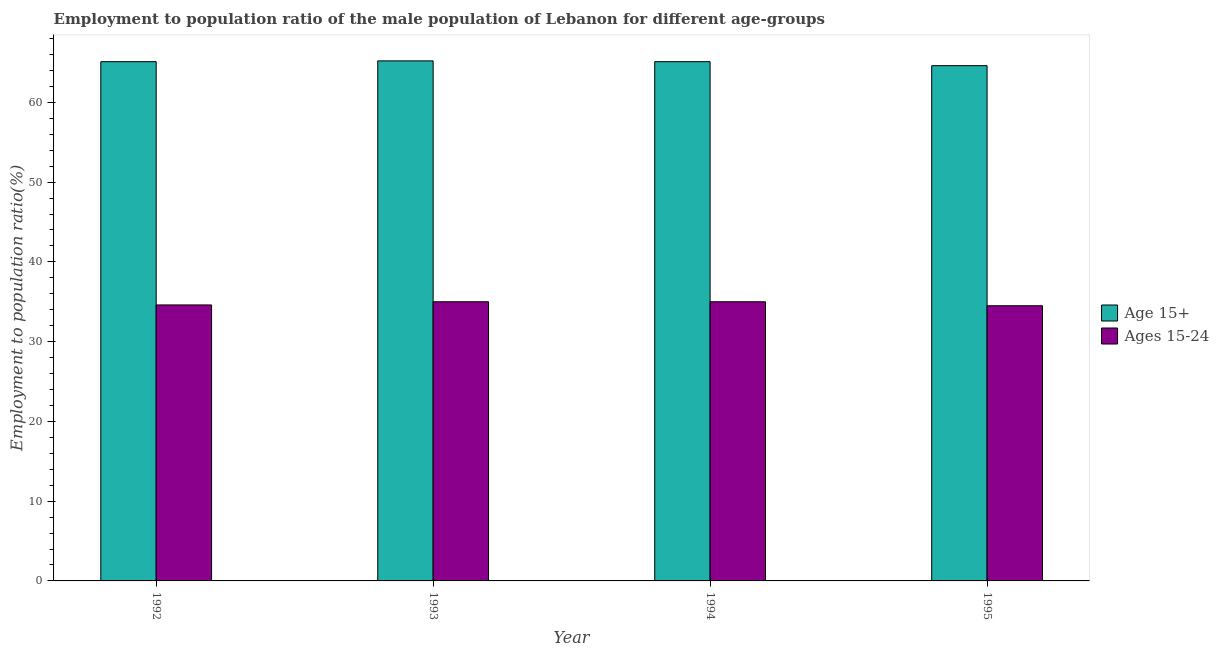How many different coloured bars are there?
Make the answer very short. 2. How many groups of bars are there?
Make the answer very short. 4. Are the number of bars on each tick of the X-axis equal?
Provide a short and direct response. Yes. How many bars are there on the 2nd tick from the left?
Offer a very short reply. 2. What is the label of the 2nd group of bars from the left?
Provide a succinct answer. 1993. What is the employment to population ratio(age 15+) in 1993?
Ensure brevity in your answer.  65.2. Across all years, what is the minimum employment to population ratio(age 15+)?
Your response must be concise. 64.6. In which year was the employment to population ratio(age 15+) maximum?
Your answer should be very brief. 1993. In which year was the employment to population ratio(age 15-24) minimum?
Your answer should be compact. 1995. What is the total employment to population ratio(age 15+) in the graph?
Your response must be concise. 260. What is the average employment to population ratio(age 15-24) per year?
Ensure brevity in your answer.  34.77. In the year 1994, what is the difference between the employment to population ratio(age 15+) and employment to population ratio(age 15-24)?
Offer a very short reply. 0. In how many years, is the employment to population ratio(age 15+) greater than 40 %?
Provide a short and direct response. 4. What is the ratio of the employment to population ratio(age 15+) in 1993 to that in 1994?
Make the answer very short. 1. Is the employment to population ratio(age 15-24) in 1992 less than that in 1994?
Give a very brief answer. Yes. What is the difference between the highest and the second highest employment to population ratio(age 15+)?
Keep it short and to the point. 0.1. What is the difference between the highest and the lowest employment to population ratio(age 15+)?
Provide a succinct answer. 0.6. What does the 2nd bar from the left in 1995 represents?
Make the answer very short. Ages 15-24. What does the 1st bar from the right in 1994 represents?
Your answer should be compact. Ages 15-24. Are the values on the major ticks of Y-axis written in scientific E-notation?
Keep it short and to the point. No. Does the graph contain grids?
Your answer should be compact. No. How many legend labels are there?
Ensure brevity in your answer.  2. How are the legend labels stacked?
Give a very brief answer. Vertical. What is the title of the graph?
Offer a very short reply. Employment to population ratio of the male population of Lebanon for different age-groups. Does "Investment" appear as one of the legend labels in the graph?
Keep it short and to the point. No. What is the label or title of the X-axis?
Your answer should be compact. Year. What is the Employment to population ratio(%) of Age 15+ in 1992?
Ensure brevity in your answer.  65.1. What is the Employment to population ratio(%) in Ages 15-24 in 1992?
Your answer should be compact. 34.6. What is the Employment to population ratio(%) in Age 15+ in 1993?
Your response must be concise. 65.2. What is the Employment to population ratio(%) of Ages 15-24 in 1993?
Keep it short and to the point. 35. What is the Employment to population ratio(%) of Age 15+ in 1994?
Your answer should be compact. 65.1. What is the Employment to population ratio(%) in Ages 15-24 in 1994?
Ensure brevity in your answer.  35. What is the Employment to population ratio(%) in Age 15+ in 1995?
Your answer should be very brief. 64.6. What is the Employment to population ratio(%) of Ages 15-24 in 1995?
Offer a very short reply. 34.5. Across all years, what is the maximum Employment to population ratio(%) of Age 15+?
Offer a terse response. 65.2. Across all years, what is the maximum Employment to population ratio(%) of Ages 15-24?
Make the answer very short. 35. Across all years, what is the minimum Employment to population ratio(%) in Age 15+?
Keep it short and to the point. 64.6. Across all years, what is the minimum Employment to population ratio(%) of Ages 15-24?
Your answer should be compact. 34.5. What is the total Employment to population ratio(%) of Age 15+ in the graph?
Your answer should be compact. 260. What is the total Employment to population ratio(%) of Ages 15-24 in the graph?
Your response must be concise. 139.1. What is the difference between the Employment to population ratio(%) of Age 15+ in 1992 and that in 1993?
Your response must be concise. -0.1. What is the difference between the Employment to population ratio(%) of Ages 15-24 in 1992 and that in 1993?
Offer a terse response. -0.4. What is the difference between the Employment to population ratio(%) in Age 15+ in 1992 and that in 1995?
Offer a terse response. 0.5. What is the difference between the Employment to population ratio(%) in Ages 15-24 in 1992 and that in 1995?
Keep it short and to the point. 0.1. What is the difference between the Employment to population ratio(%) of Age 15+ in 1993 and that in 1995?
Your answer should be very brief. 0.6. What is the difference between the Employment to population ratio(%) of Age 15+ in 1994 and that in 1995?
Provide a succinct answer. 0.5. What is the difference between the Employment to population ratio(%) in Age 15+ in 1992 and the Employment to population ratio(%) in Ages 15-24 in 1993?
Offer a very short reply. 30.1. What is the difference between the Employment to population ratio(%) in Age 15+ in 1992 and the Employment to population ratio(%) in Ages 15-24 in 1994?
Your answer should be very brief. 30.1. What is the difference between the Employment to population ratio(%) in Age 15+ in 1992 and the Employment to population ratio(%) in Ages 15-24 in 1995?
Keep it short and to the point. 30.6. What is the difference between the Employment to population ratio(%) in Age 15+ in 1993 and the Employment to population ratio(%) in Ages 15-24 in 1994?
Make the answer very short. 30.2. What is the difference between the Employment to population ratio(%) in Age 15+ in 1993 and the Employment to population ratio(%) in Ages 15-24 in 1995?
Offer a terse response. 30.7. What is the difference between the Employment to population ratio(%) of Age 15+ in 1994 and the Employment to population ratio(%) of Ages 15-24 in 1995?
Give a very brief answer. 30.6. What is the average Employment to population ratio(%) of Ages 15-24 per year?
Make the answer very short. 34.77. In the year 1992, what is the difference between the Employment to population ratio(%) in Age 15+ and Employment to population ratio(%) in Ages 15-24?
Offer a terse response. 30.5. In the year 1993, what is the difference between the Employment to population ratio(%) of Age 15+ and Employment to population ratio(%) of Ages 15-24?
Ensure brevity in your answer.  30.2. In the year 1994, what is the difference between the Employment to population ratio(%) of Age 15+ and Employment to population ratio(%) of Ages 15-24?
Provide a short and direct response. 30.1. In the year 1995, what is the difference between the Employment to population ratio(%) of Age 15+ and Employment to population ratio(%) of Ages 15-24?
Offer a very short reply. 30.1. What is the ratio of the Employment to population ratio(%) of Age 15+ in 1992 to that in 1993?
Offer a very short reply. 1. What is the ratio of the Employment to population ratio(%) of Ages 15-24 in 1992 to that in 1993?
Provide a short and direct response. 0.99. What is the ratio of the Employment to population ratio(%) of Age 15+ in 1992 to that in 1994?
Provide a short and direct response. 1. What is the ratio of the Employment to population ratio(%) in Age 15+ in 1992 to that in 1995?
Offer a terse response. 1.01. What is the ratio of the Employment to population ratio(%) in Age 15+ in 1993 to that in 1994?
Provide a short and direct response. 1. What is the ratio of the Employment to population ratio(%) in Age 15+ in 1993 to that in 1995?
Make the answer very short. 1.01. What is the ratio of the Employment to population ratio(%) of Ages 15-24 in 1993 to that in 1995?
Your answer should be compact. 1.01. What is the ratio of the Employment to population ratio(%) of Age 15+ in 1994 to that in 1995?
Make the answer very short. 1.01. What is the ratio of the Employment to population ratio(%) of Ages 15-24 in 1994 to that in 1995?
Offer a terse response. 1.01. What is the difference between the highest and the second highest Employment to population ratio(%) in Age 15+?
Ensure brevity in your answer.  0.1. What is the difference between the highest and the second highest Employment to population ratio(%) in Ages 15-24?
Your answer should be compact. 0. What is the difference between the highest and the lowest Employment to population ratio(%) of Age 15+?
Give a very brief answer. 0.6. 